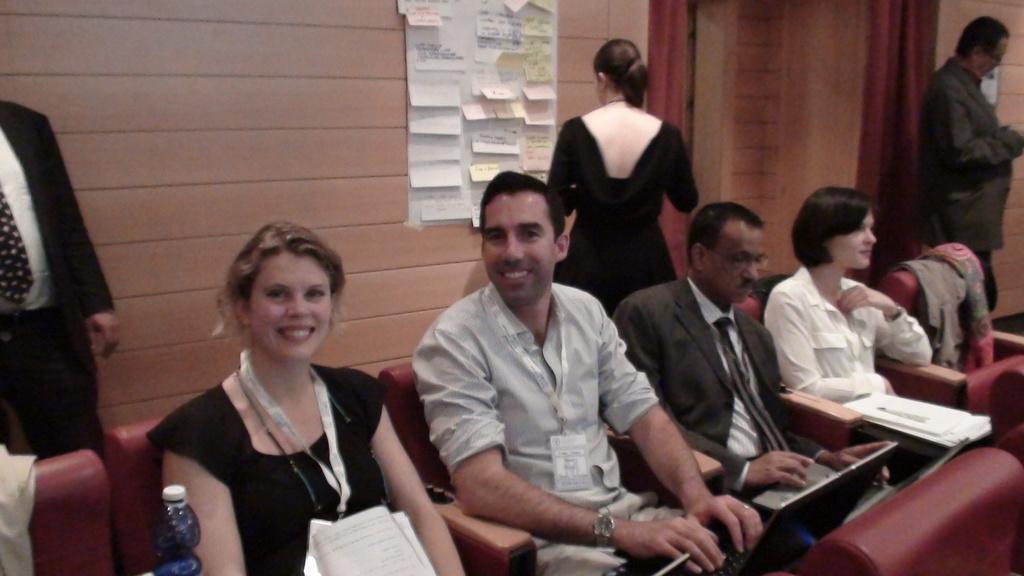In one or two sentences, can you explain what this image depicts? In this image there are some persons are sitting at bottom of this image and there is a bottle at left side of this image and there is one person standing at left side of this image is wearing black color dress and there is a wall in the background. There is one woman standing in middle of this image is wearing black color dress and one person standing at right side of this image , and there is a wall poster at top of this image and there are some chairs at bottom of this image. 